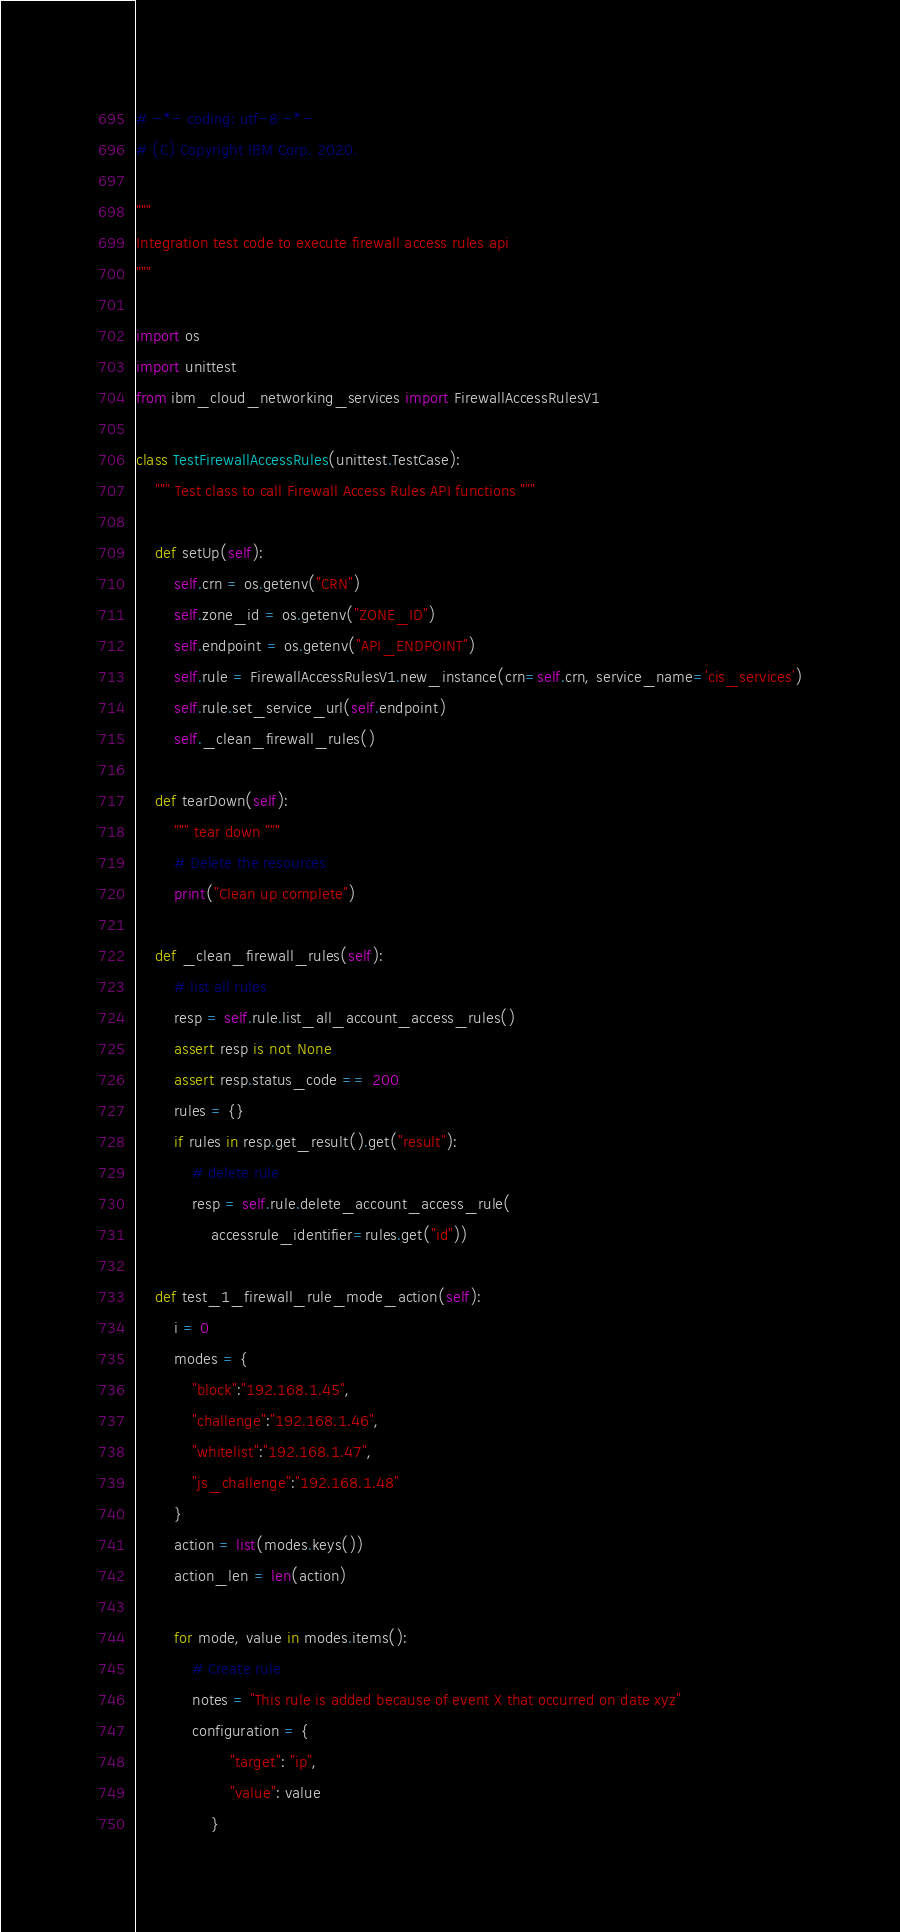Convert code to text. <code><loc_0><loc_0><loc_500><loc_500><_Python_># -*- coding: utf-8 -*-
# (C) Copyright IBM Corp. 2020.

"""
Integration test code to execute firewall access rules api
"""

import os
import unittest
from ibm_cloud_networking_services import FirewallAccessRulesV1

class TestFirewallAccessRules(unittest.TestCase):
    """ Test class to call Firewall Access Rules API functions """

    def setUp(self):
        self.crn = os.getenv("CRN")
        self.zone_id = os.getenv("ZONE_ID")
        self.endpoint = os.getenv("API_ENDPOINT")
        self.rule = FirewallAccessRulesV1.new_instance(crn=self.crn, service_name='cis_services')
        self.rule.set_service_url(self.endpoint)
        self._clean_firewall_rules()

    def tearDown(self):
        """ tear down """
        # Delete the resources
        print("Clean up complete")

    def _clean_firewall_rules(self):
        # list all rules
        resp = self.rule.list_all_account_access_rules()
        assert resp is not None
        assert resp.status_code == 200
        rules = {}
        if rules in resp.get_result().get("result"):
            # delete rule
            resp = self.rule.delete_account_access_rule(
                accessrule_identifier=rules.get("id"))

    def test_1_firewall_rule_mode_action(self):
        i = 0
        modes = {
            "block":"192.168.1.45",
            "challenge":"192.168.1.46",
            "whitelist":"192.168.1.47",
            "js_challenge":"192.168.1.48"
        }
        action = list(modes.keys())
        action_len = len(action)

        for mode, value in modes.items():
            # Create rule
            notes = "This rule is added because of event X that occurred on date xyz"
            configuration = {
                    "target": "ip",
                    "value": value
                }</code> 